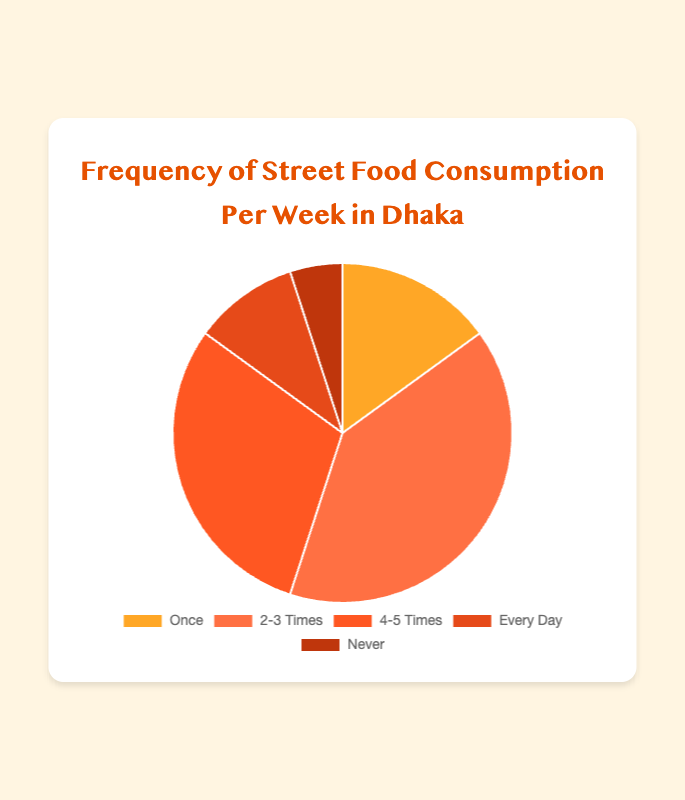What's the most common frequency of street food consumption per week? The largest segment on the pie chart represents "2-3 Times" with 40%.
Answer: 2-3 Times What percentage of people never eat street food? The segment labeled "Never" accounts for 5% of the pie chart.
Answer: 5% How does the percentage of people who eat street food every day compare to those who eat it once a week? The "Every Day" category is 10%, while the "Once" category is 15%. 10% is less than 15%.
Answer: Less What is the combined percentage of people who eat street food either 4-5 times or every day? The percentages for "4-5 Times" and "Every Day" are 30% and 10%, respectively. Adding these together: 30% + 10% = 40%.
Answer: 40% If you exclude the people who never eat street food, what fraction of the remaining people eat it 2-3 times a week? Excluding the 5% who never eat street food, the remaining percentage is 100% - 5% = 95%. The "2-3 Times" category is 40%, so the fraction is 40/95.
Answer: 40/95 What percentage more frequently do people eat street food 2-3 times a week compared to 4-5 times a week? The percentage for "2-3 Times" is 40% and for "4-5 Times" is 30%. The difference is 40% - 30% = 10%.
Answer: 10% Which category has the smallest percentage of street food consumption? The smallest segment on the chart is "Never" with 5%.
Answer: Never How much larger is the percentage of people who eat street food 4-5 times compared to those who eat it once? The percentage for "4-5 Times" is 30%, and for "Once" is 15%. The difference is 30% - 15% = 15%.
Answer: 15% What color represents the "Every Day" category on the pie chart? The segment for "Every Day" is colored in dark orange.
Answer: Dark orange What is the ratio of people who eat street food 2-3 times to those who eat it once a week? The percentage for "2-3 Times" is 40%, and for "Once" is 15%. The ratio is 40:15, which simplifies to 8:3.
Answer: 8:3 